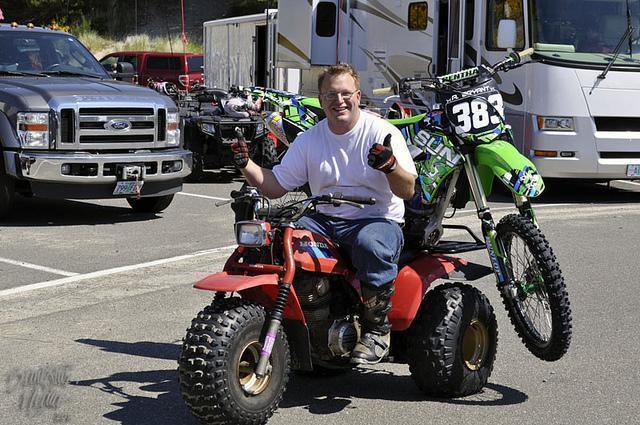Why does he have a bike on the back of his vehicle?
Make your selection from the four choices given to correctly answer the question.
Options: Transporting it, stealing it, found it, selling it. Transporting it. 